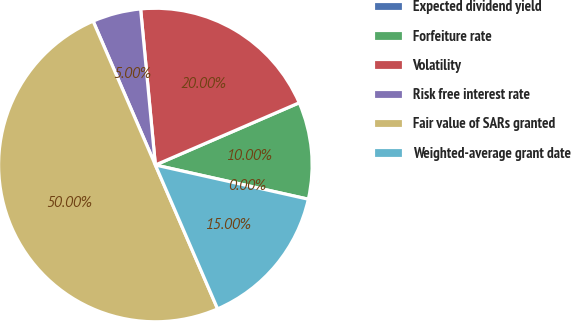Convert chart to OTSL. <chart><loc_0><loc_0><loc_500><loc_500><pie_chart><fcel>Expected dividend yield<fcel>Forfeiture rate<fcel>Volatility<fcel>Risk free interest rate<fcel>Fair value of SARs granted<fcel>Weighted-average grant date<nl><fcel>0.0%<fcel>10.0%<fcel>20.0%<fcel>5.0%<fcel>50.0%<fcel>15.0%<nl></chart> 